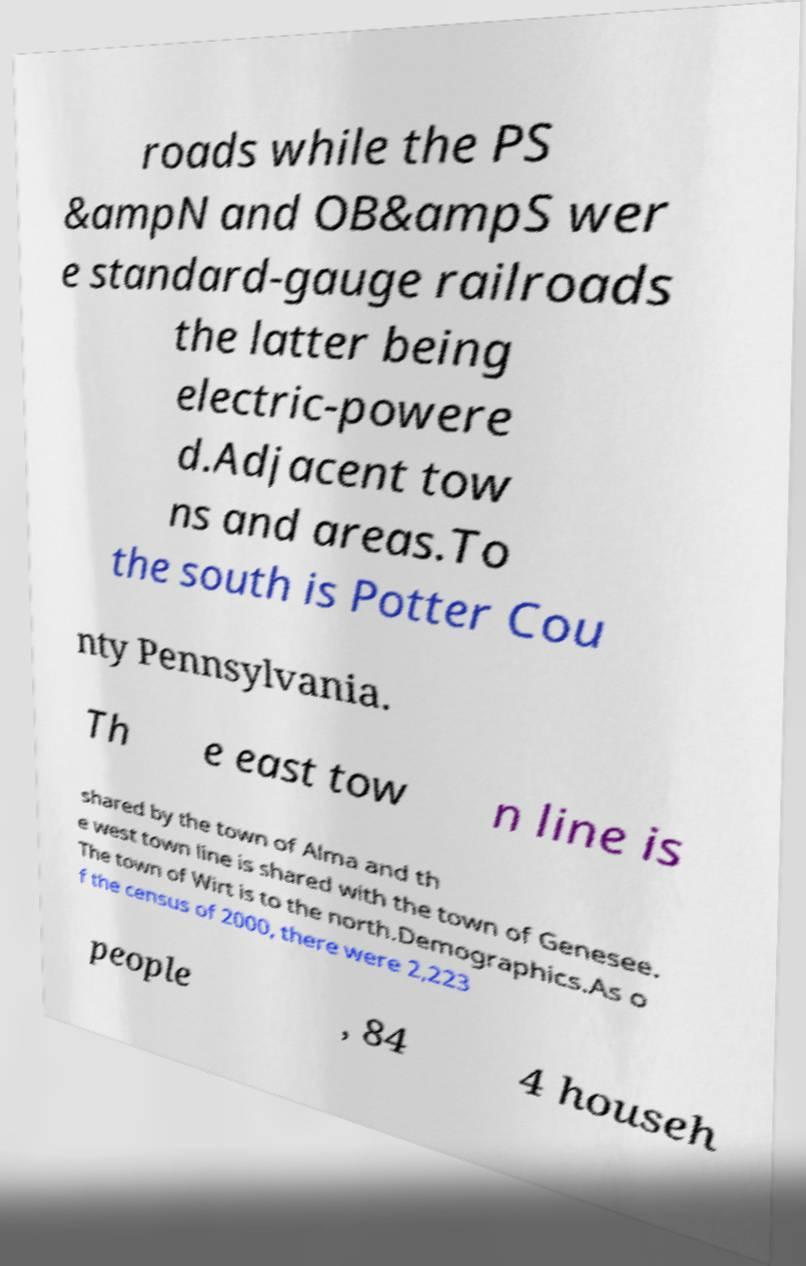Please identify and transcribe the text found in this image. roads while the PS &ampN and OB&ampS wer e standard-gauge railroads the latter being electric-powere d.Adjacent tow ns and areas.To the south is Potter Cou nty Pennsylvania. Th e east tow n line is shared by the town of Alma and th e west town line is shared with the town of Genesee. The town of Wirt is to the north.Demographics.As o f the census of 2000, there were 2,223 people , 84 4 househ 